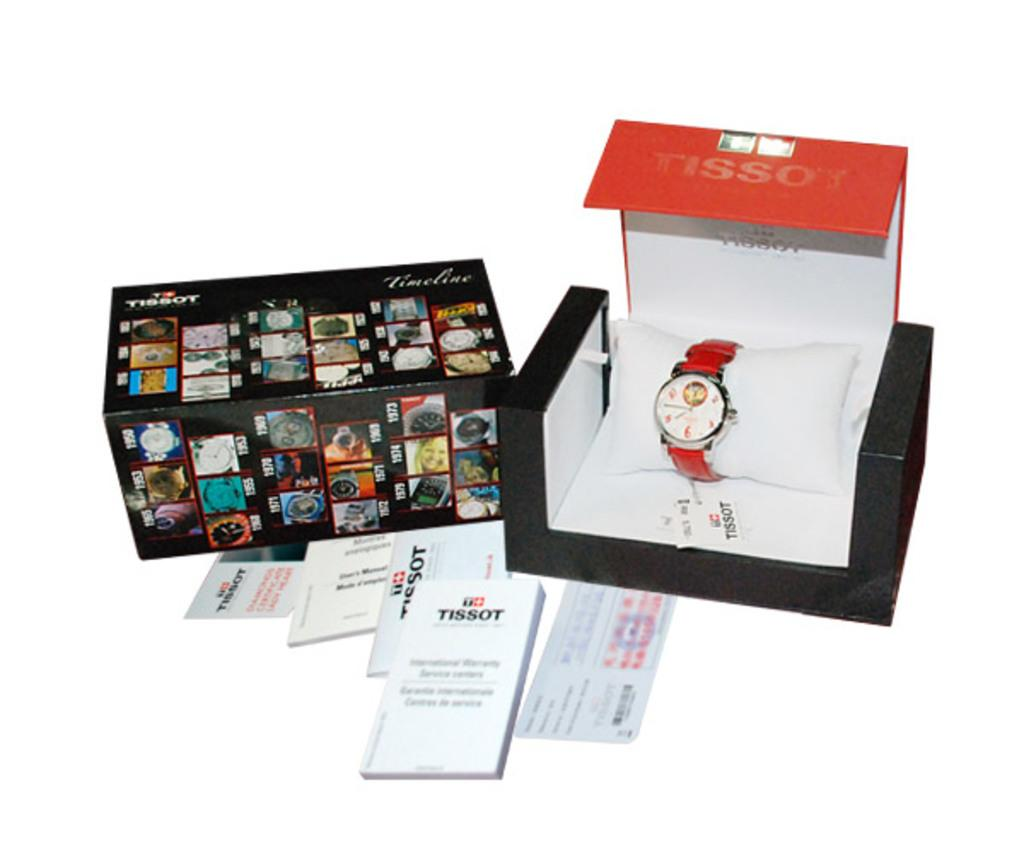What is inside the box that is visible in the image? There is a watch in a box in the image. What else can be seen in the box in the image? There is a box with pictures in the image. What is placed on the surface in the image? There are papers placed on the surface in the image. What type of good-bye is being said in the image? There is no indication of anyone saying good-bye in the image. What treatment is being administered to the watch in the image? There is no treatment being administered to the watch in the image; it is simply placed in a box. 